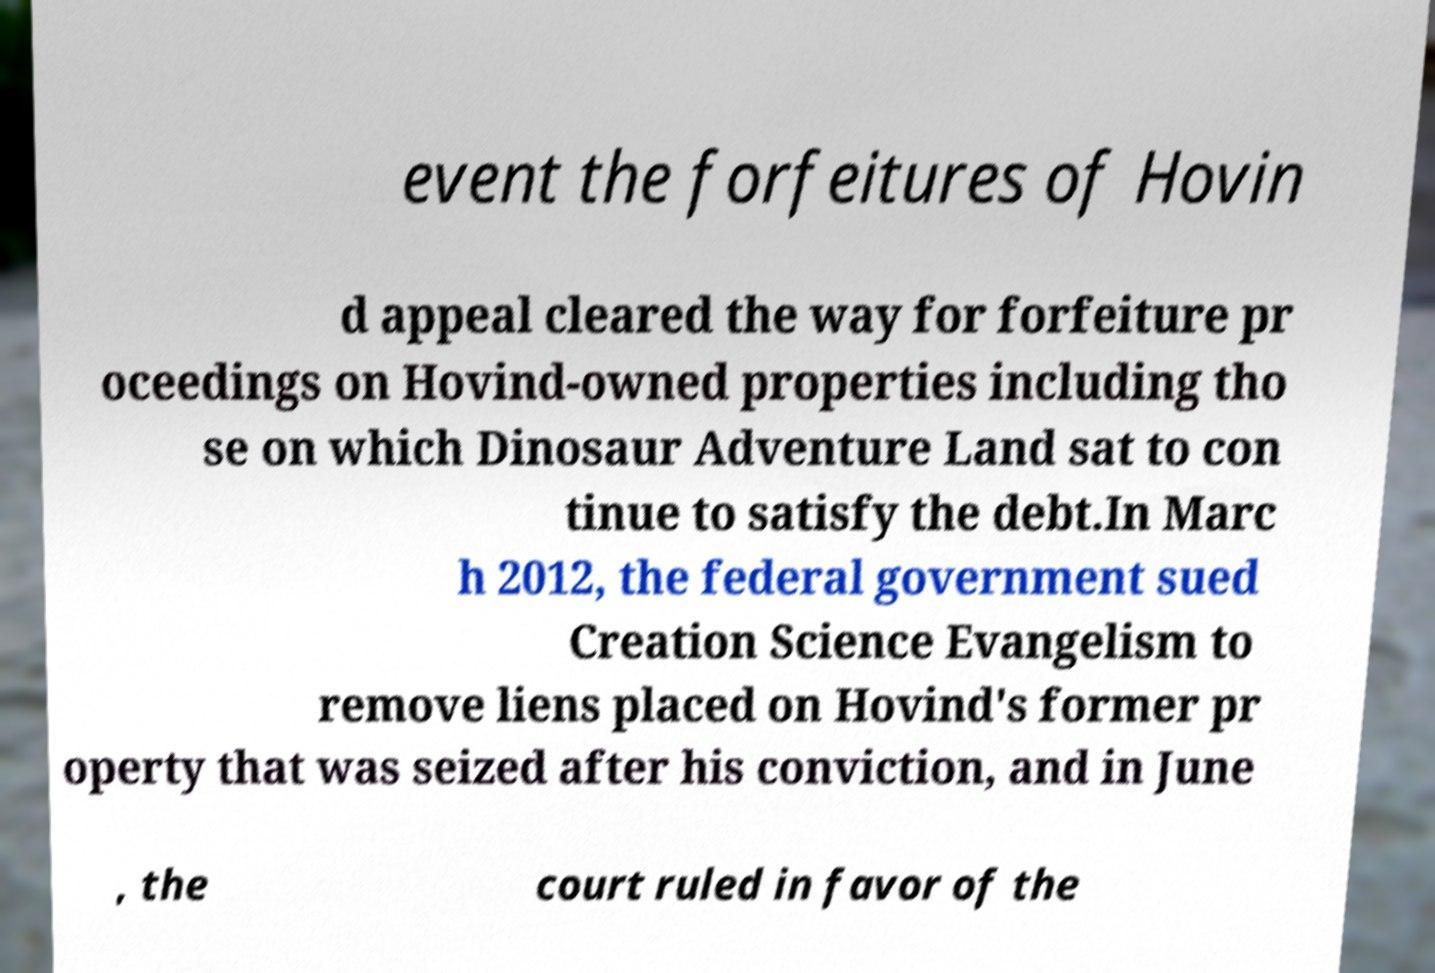Please identify and transcribe the text found in this image. event the forfeitures of Hovin d appeal cleared the way for forfeiture pr oceedings on Hovind-owned properties including tho se on which Dinosaur Adventure Land sat to con tinue to satisfy the debt.In Marc h 2012, the federal government sued Creation Science Evangelism to remove liens placed on Hovind's former pr operty that was seized after his conviction, and in June , the court ruled in favor of the 